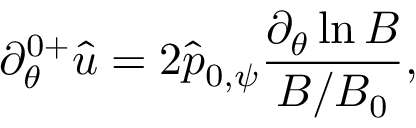<formula> <loc_0><loc_0><loc_500><loc_500>\partial _ { \theta } ^ { 0 + } \hat { u } = 2 \hat { p } _ { 0 , \psi } \frac { \partial _ { \theta } \ln B } { B / B _ { 0 } } ,</formula> 